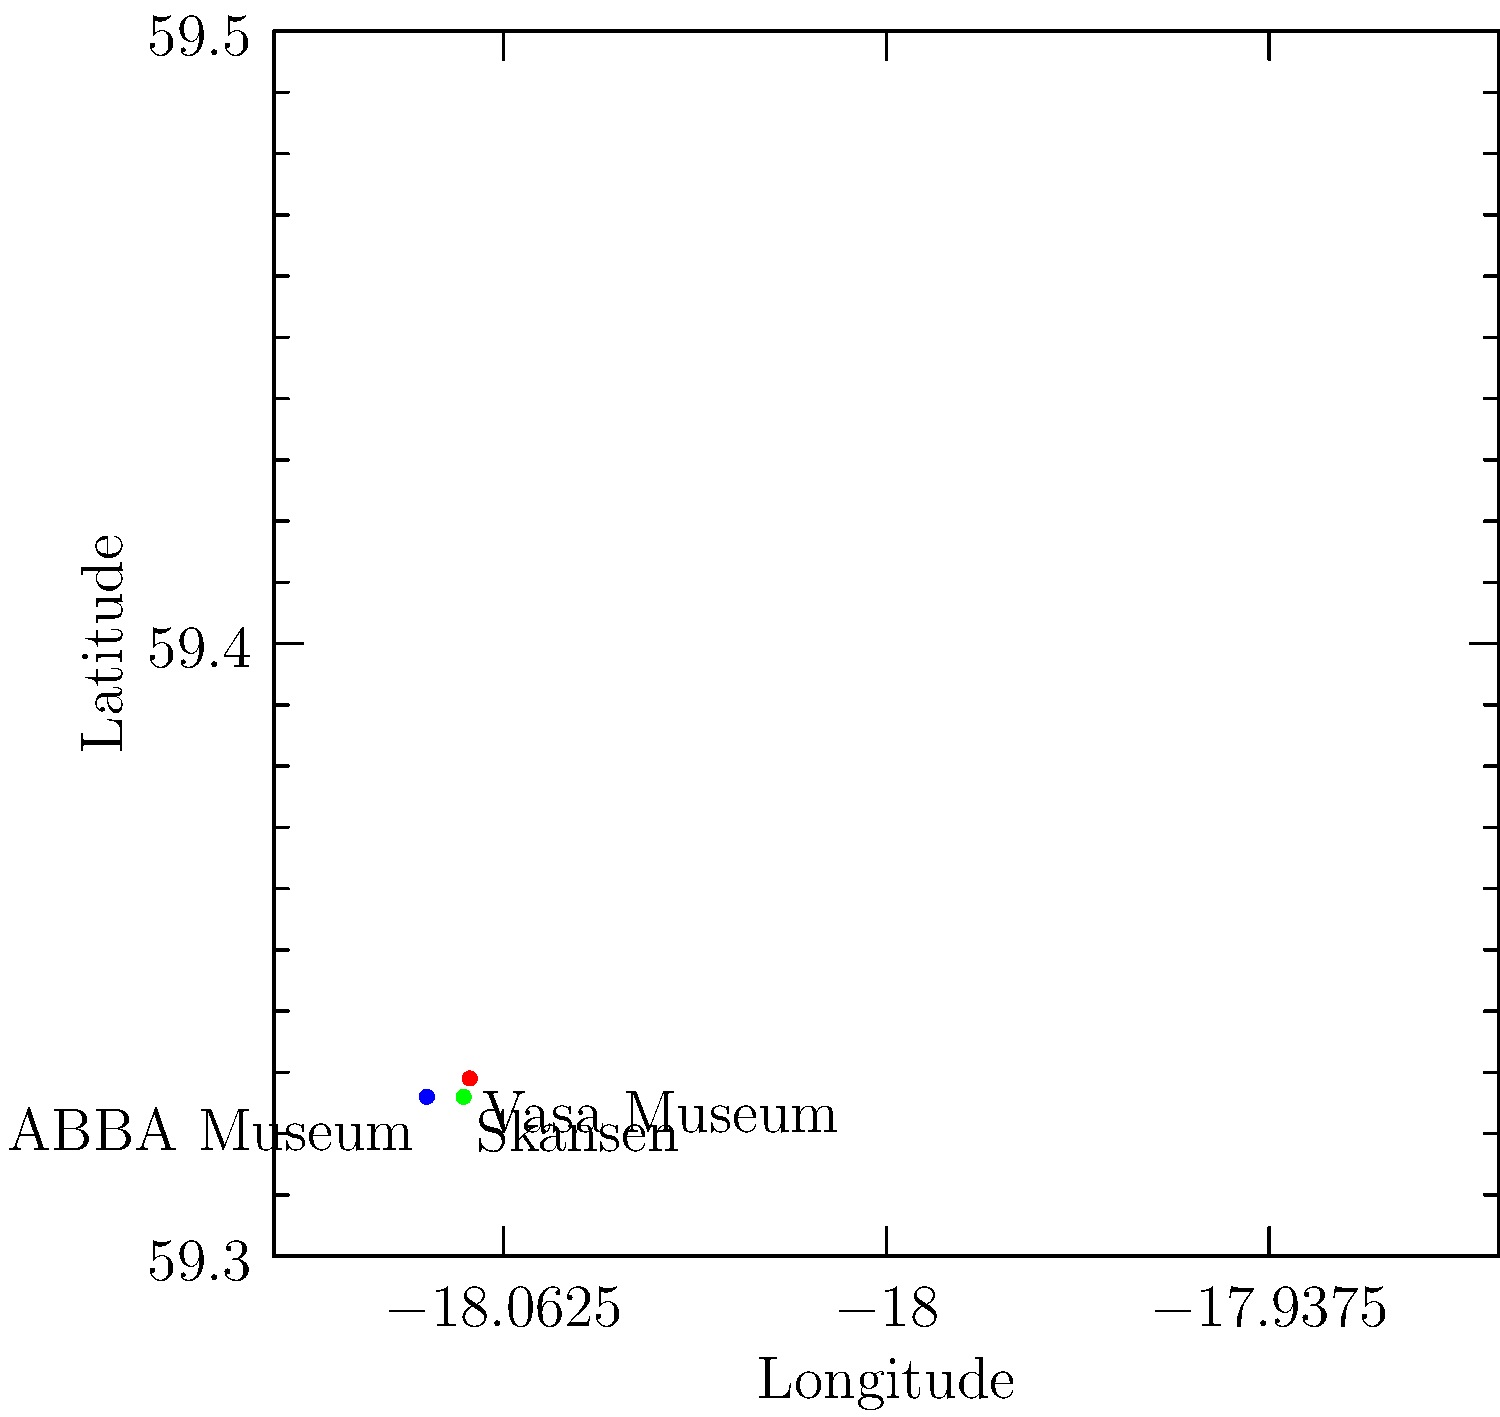Based on the coordinate system shown, which tourist attraction in Stockholm is located at approximately (59.329°N, 18.068°E)? To answer this question, we need to follow these steps:

1. Understand the coordinate system:
   - The x-axis represents longitude (East-West)
   - The y-axis represents latitude (North-South)

2. Locate the given coordinates on the graph:
   - Latitude: 59.329°N
   - Longitude: 18.068°E (Note: The graph shows negative values, but Stockholm is in the Eastern hemisphere, so we use the positive equivalent)

3. Find the point on the graph that corresponds to these coordinates:
   - The point is marked with a red dot

4. Identify the label associated with this point:
   - The label next to the red dot reads "Vasa Museum"

Therefore, the tourist attraction located at approximately (59.329°N, 18.068°E) is the Vasa Museum.
Answer: Vasa Museum 